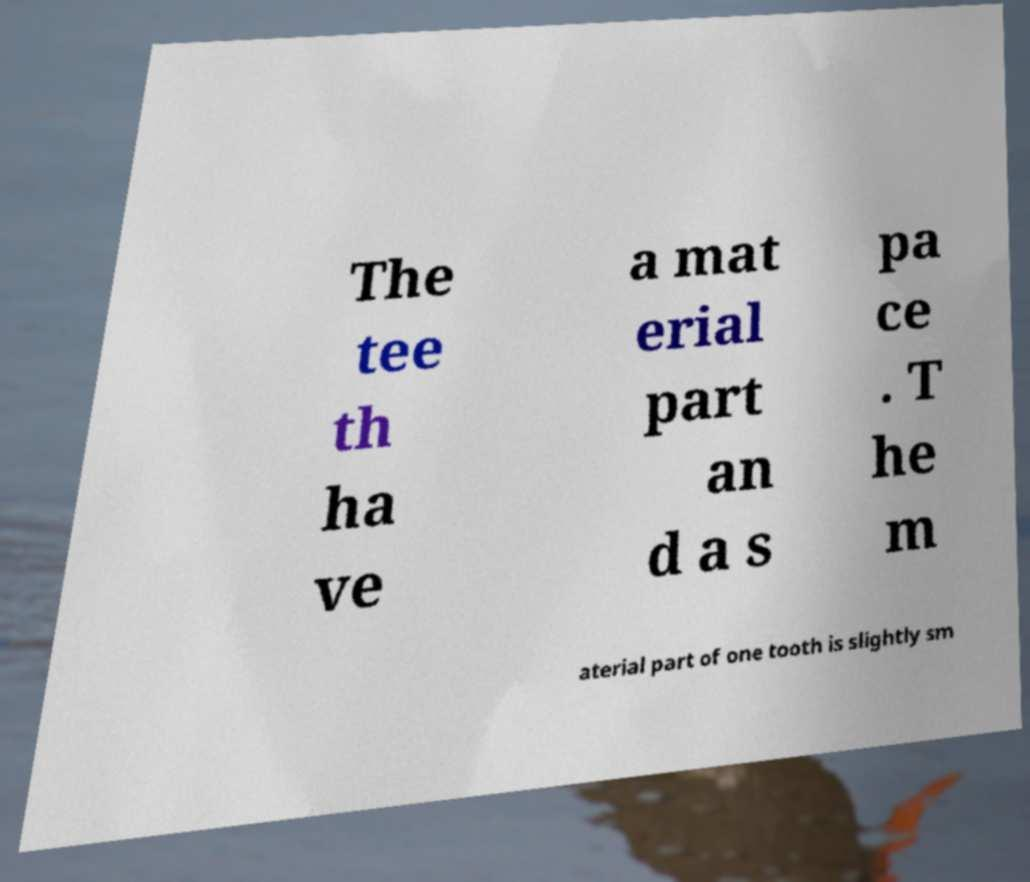Please read and relay the text visible in this image. What does it say? The tee th ha ve a mat erial part an d a s pa ce . T he m aterial part of one tooth is slightly sm 